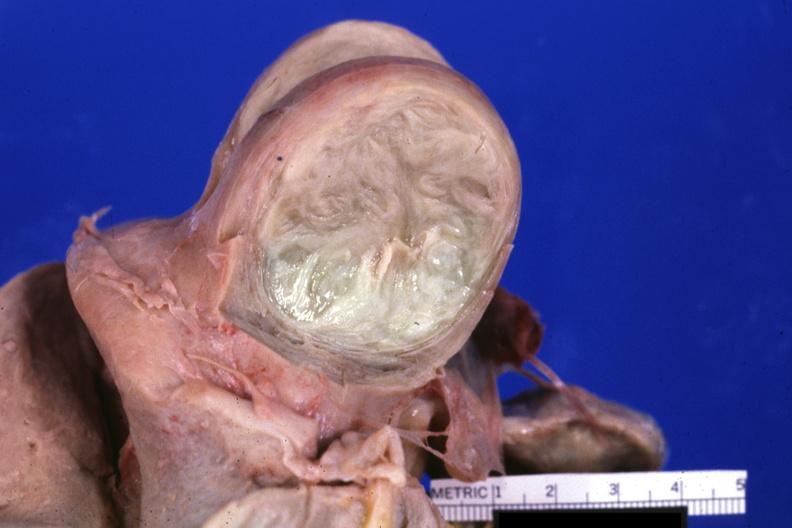s female reproductive present?
Answer the question using a single word or phrase. Yes 